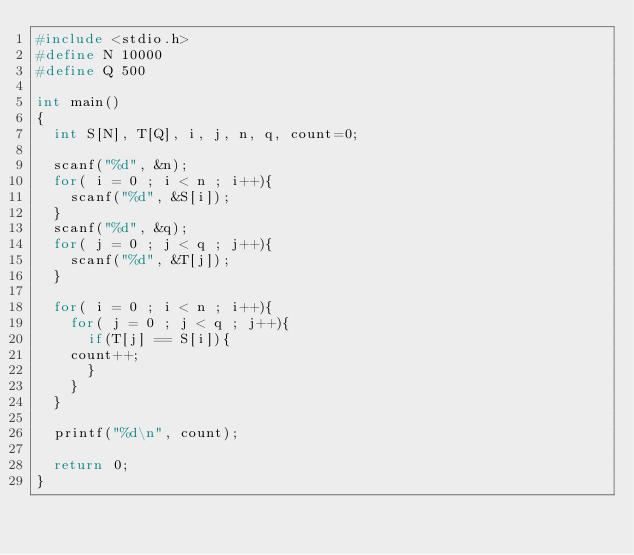Convert code to text. <code><loc_0><loc_0><loc_500><loc_500><_C_>#include <stdio.h>
#define N 10000
#define Q 500

int main()
{
  int S[N], T[Q], i, j, n, q, count=0;

  scanf("%d", &n);
  for( i = 0 ; i < n ; i++){
    scanf("%d", &S[i]);
  }
  scanf("%d", &q);
  for( j = 0 ; j < q ; j++){
    scanf("%d", &T[j]);
  }
  
  for( i = 0 ; i < n ; i++){
    for( j = 0 ; j < q ; j++){
      if(T[j] == S[i]){
	count++;
      }
    }
  }

  printf("%d\n", count);
  
  return 0;
}</code> 